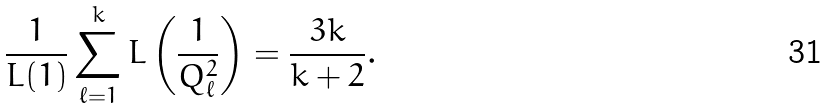Convert formula to latex. <formula><loc_0><loc_0><loc_500><loc_500>\frac { 1 } { L ( 1 ) } \sum _ { \ell = 1 } ^ { k } L \left ( \frac { 1 } { Q _ { \ell } ^ { 2 } } \right ) = \frac { 3 k } { k + 2 } .</formula> 